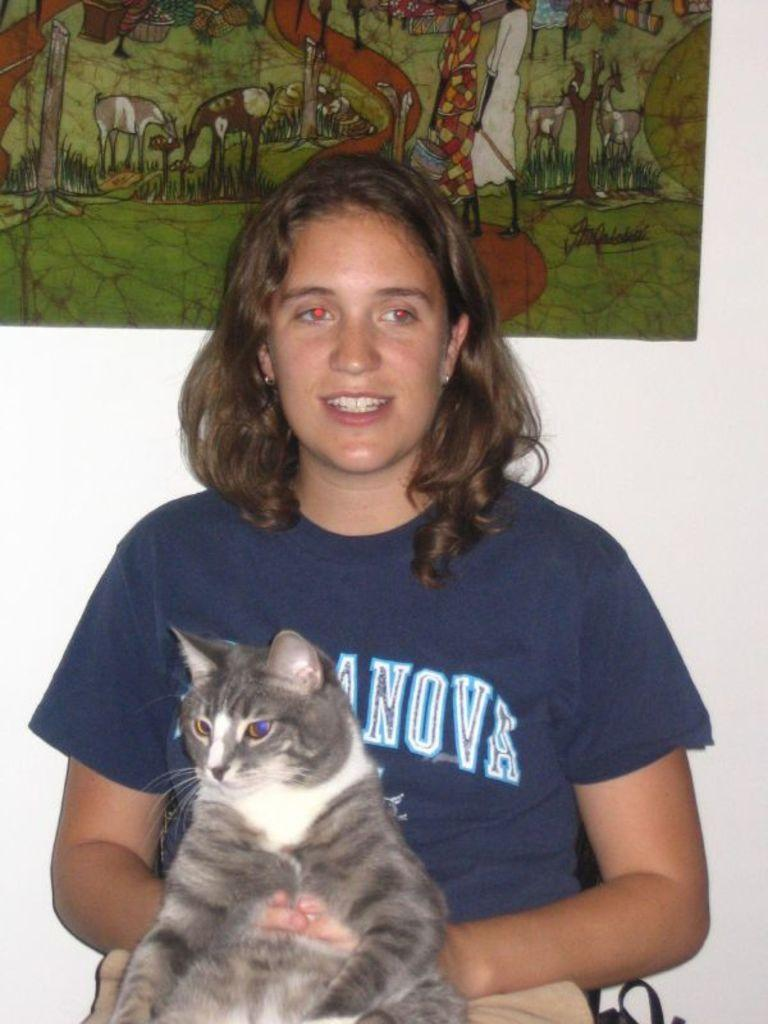Who is the main subject in the image? There is a woman in the image. What is the woman doing in the image? The woman is sitting. What is the woman holding in her lap? The woman is holding a cat in her lap. What can be seen in the background of the image? There is a wall and a photo in the background of the image. How many friends does the woman have in the image? The image does not show any friends; it only features the woman and a cat. 